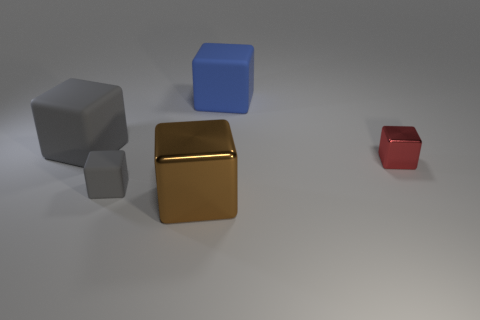Subtract all large brown shiny cubes. How many cubes are left? 4 Subtract all blue blocks. How many blocks are left? 4 Add 4 big yellow cylinders. How many objects exist? 9 Subtract all cyan blocks. Subtract all blue spheres. How many blocks are left? 5 Add 3 small gray rubber cubes. How many small gray rubber cubes are left? 4 Add 4 blue blocks. How many blue blocks exist? 5 Subtract 0 brown spheres. How many objects are left? 5 Subtract all tiny red metal things. Subtract all big gray blocks. How many objects are left? 3 